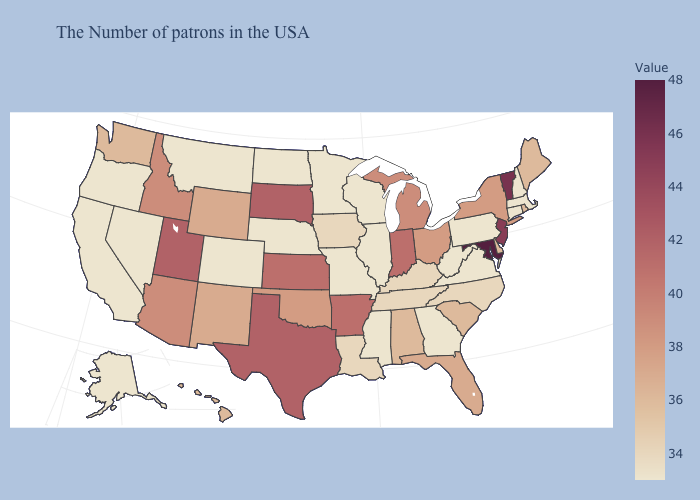Does Maryland have the highest value in the USA?
Concise answer only. Yes. Does Virginia have the lowest value in the USA?
Short answer required. Yes. Does Maryland have the highest value in the USA?
Be succinct. Yes. Which states have the lowest value in the South?
Keep it brief. Virginia, West Virginia, Georgia, Mississippi. Among the states that border Wyoming , does Montana have the highest value?
Quick response, please. No. Among the states that border Delaware , which have the lowest value?
Quick response, please. Pennsylvania. Does Vermont have a higher value than Iowa?
Be succinct. Yes. 